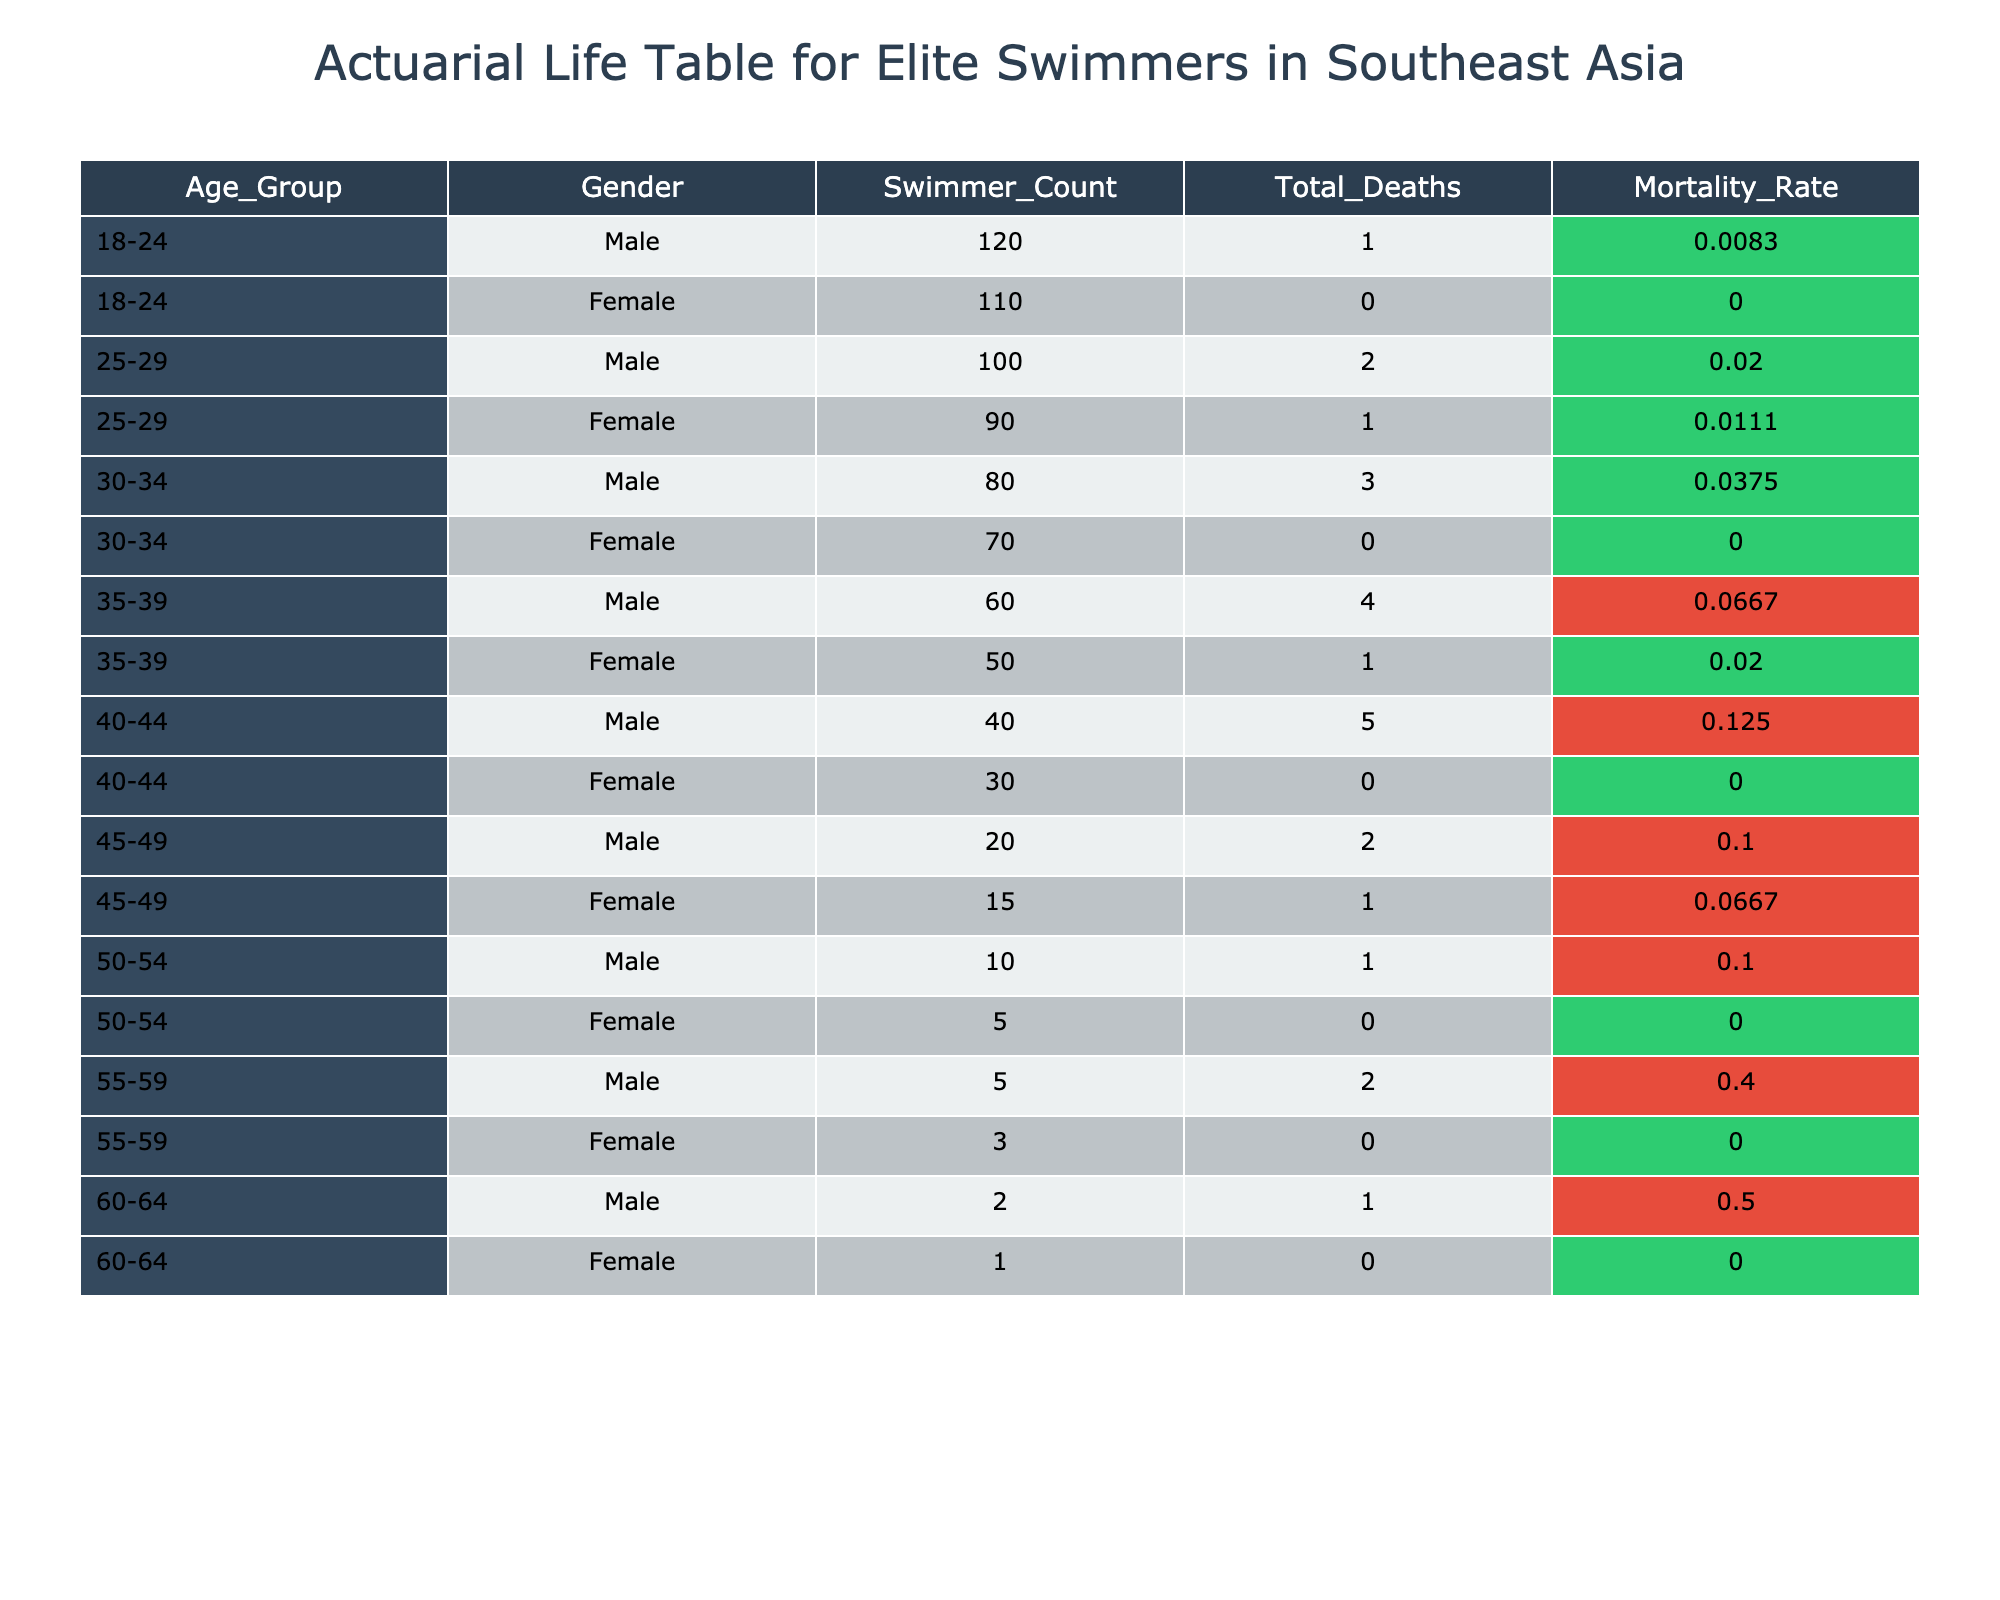What is the mortality rate for male swimmers aged 35-39? The table shows the mortality rate for male swimmers aged 35-39 is listed in the row corresponding to that age group. It states that for this group, the mortality rate is 0.0667.
Answer: 0.0667 How many total deaths were recorded for female swimmers aged 25-29? Looking at the row for female swimmers aged 25-29, we see that there is 1 total death recorded in this age group.
Answer: 1 What is the difference in mortality rates between male and female swimmers aged 40-44? For male swimmers aged 40-44, the mortality rate is 0.1250, and for female swimmers in the same age group, it is 0.0000. The difference is 0.1250 - 0.0000 = 0.1250.
Answer: 0.1250 Are there any deaths recorded for female swimmers aged 50-54? Checking the row for female swimmers aged 50-54, the total deaths are listed as 0, indicating no deaths occurred in this age group.
Answer: No What is the average mortality rate for male swimmers across all age groups? To find the average, we sum the mortality rates for all male age groups: 0.0083 + 0.0200 + 0.0375 + 0.0667 + 0.1250 + 0.1000 + 0.1000 + 0.4000 + 0.5000 = 0.9585. There are 9 groups, so the average is 0.9585 / 9 ≈ 0.1065.
Answer: 0.1065 What percentage of the total deaths recorded in the 18-24 male age group is due to swimming-related incidents? Since there is one total death for the 18-24 age group and no specific detail given, we would assume all deaths are swimming-related. Therefore, the percentage is (1 / 1) * 100 = 100%.
Answer: 100% Which age group has the highest recorded mortality rate for male swimmers? Reviewing the mortality rates for male swimmers, the highest is 0.5000 for the 60-64 age group.
Answer: 60-64 How many male swimmers aged 55-59 are recorded in the table? The table shows 5 male swimmers recorded in the 55-59 age group.
Answer: 5 